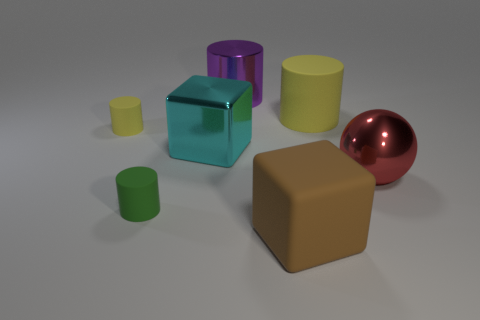There is a tiny object that is the same material as the green cylinder; what shape is it?
Provide a short and direct response. Cylinder. Is there anything else that is the same color as the big rubber cylinder?
Give a very brief answer. Yes. There is a yellow thing on the left side of the yellow matte cylinder to the right of the small yellow matte thing; what is it made of?
Make the answer very short. Rubber. Is there another big object of the same shape as the big cyan thing?
Give a very brief answer. Yes. What number of other objects are there of the same shape as the brown thing?
Your answer should be compact. 1. There is a rubber thing that is behind the big cyan shiny block and on the right side of the small yellow cylinder; what is its shape?
Your response must be concise. Cylinder. There is a yellow matte cylinder on the right side of the big purple cylinder; what size is it?
Keep it short and to the point. Large. Is the size of the cyan metallic cube the same as the red object?
Your answer should be compact. Yes. Is the number of tiny cylinders on the right side of the tiny yellow cylinder less than the number of yellow matte cylinders in front of the rubber block?
Offer a terse response. No. There is a object that is both to the left of the purple shiny thing and in front of the large cyan metallic block; what is its size?
Ensure brevity in your answer.  Small. 